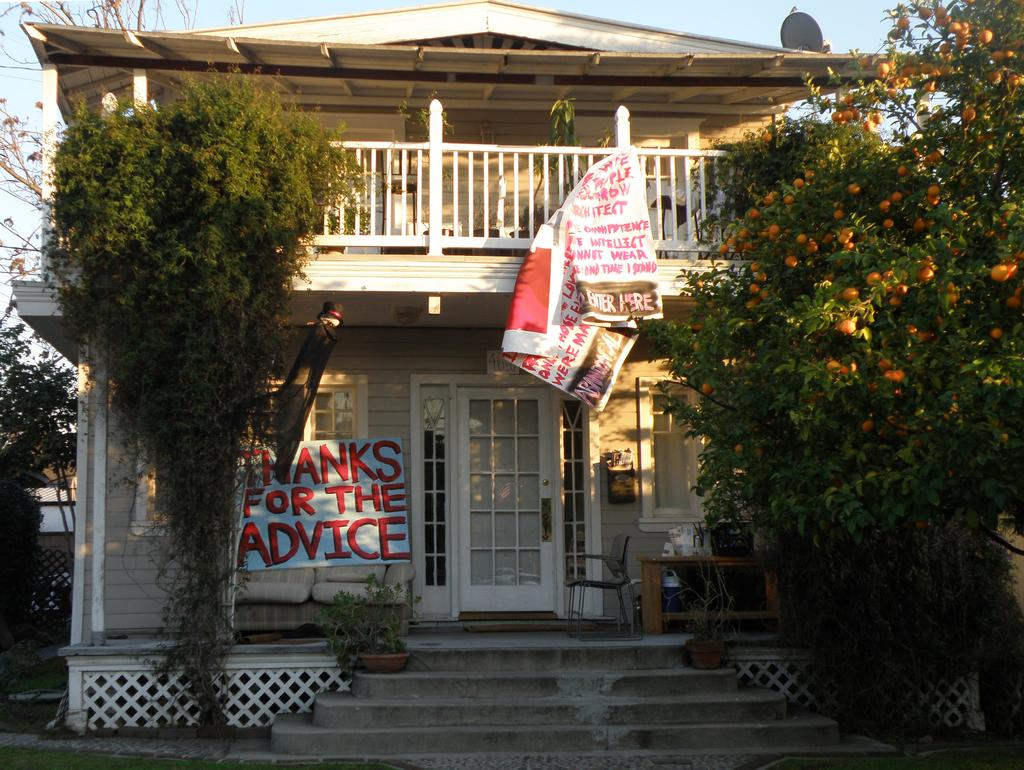<image>
Render a clear and concise summary of the photo. A picture of a house with a banner on the porch reading thanks for the advice. 